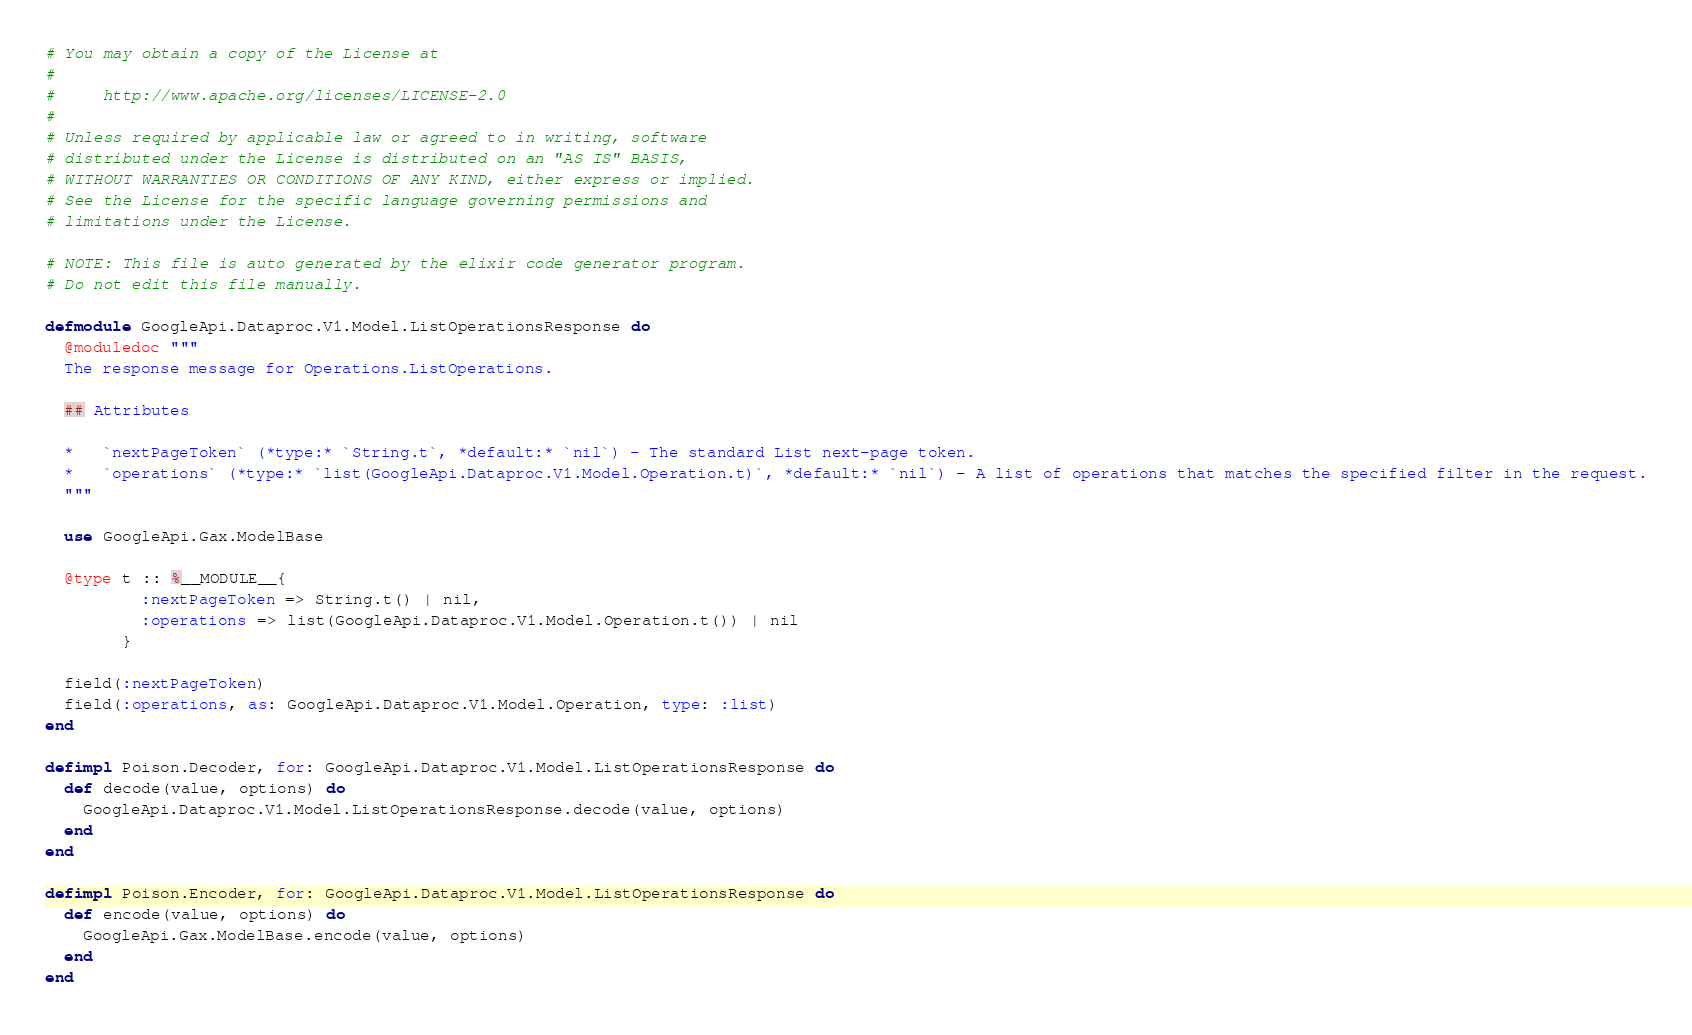Convert code to text. <code><loc_0><loc_0><loc_500><loc_500><_Elixir_># You may obtain a copy of the License at
#
#     http://www.apache.org/licenses/LICENSE-2.0
#
# Unless required by applicable law or agreed to in writing, software
# distributed under the License is distributed on an "AS IS" BASIS,
# WITHOUT WARRANTIES OR CONDITIONS OF ANY KIND, either express or implied.
# See the License for the specific language governing permissions and
# limitations under the License.

# NOTE: This file is auto generated by the elixir code generator program.
# Do not edit this file manually.

defmodule GoogleApi.Dataproc.V1.Model.ListOperationsResponse do
  @moduledoc """
  The response message for Operations.ListOperations.

  ## Attributes

  *   `nextPageToken` (*type:* `String.t`, *default:* `nil`) - The standard List next-page token.
  *   `operations` (*type:* `list(GoogleApi.Dataproc.V1.Model.Operation.t)`, *default:* `nil`) - A list of operations that matches the specified filter in the request.
  """

  use GoogleApi.Gax.ModelBase

  @type t :: %__MODULE__{
          :nextPageToken => String.t() | nil,
          :operations => list(GoogleApi.Dataproc.V1.Model.Operation.t()) | nil
        }

  field(:nextPageToken)
  field(:operations, as: GoogleApi.Dataproc.V1.Model.Operation, type: :list)
end

defimpl Poison.Decoder, for: GoogleApi.Dataproc.V1.Model.ListOperationsResponse do
  def decode(value, options) do
    GoogleApi.Dataproc.V1.Model.ListOperationsResponse.decode(value, options)
  end
end

defimpl Poison.Encoder, for: GoogleApi.Dataproc.V1.Model.ListOperationsResponse do
  def encode(value, options) do
    GoogleApi.Gax.ModelBase.encode(value, options)
  end
end
</code> 